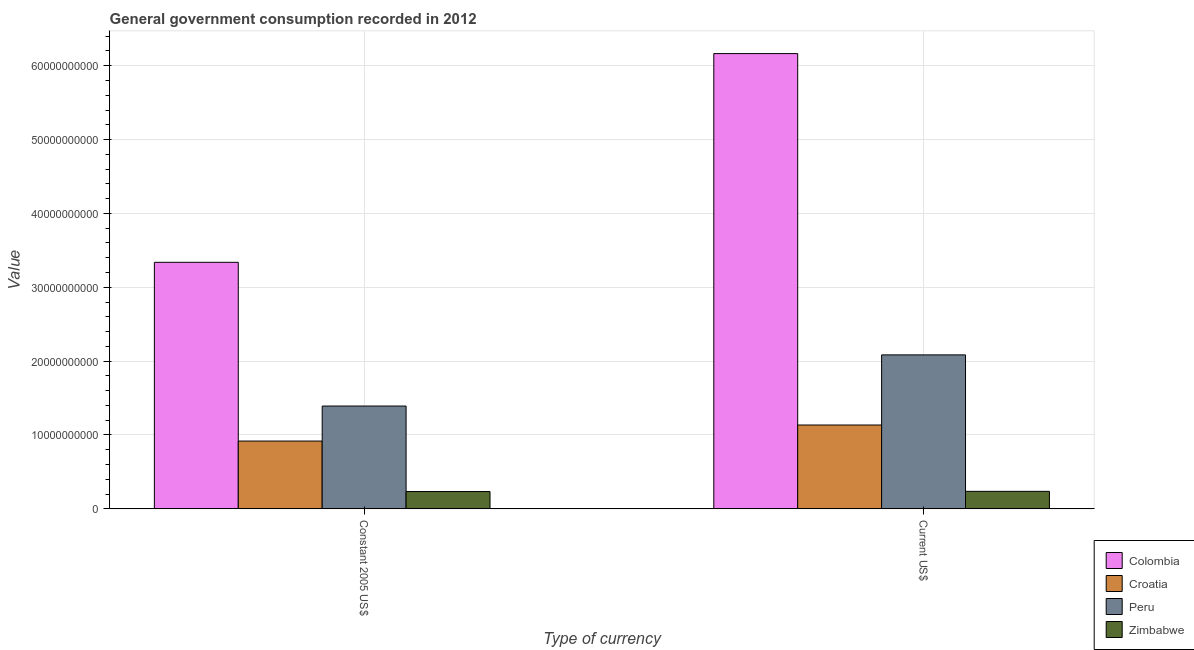Are the number of bars per tick equal to the number of legend labels?
Provide a succinct answer. Yes. How many bars are there on the 2nd tick from the left?
Keep it short and to the point. 4. How many bars are there on the 2nd tick from the right?
Keep it short and to the point. 4. What is the label of the 2nd group of bars from the left?
Provide a short and direct response. Current US$. What is the value consumed in constant 2005 us$ in Colombia?
Offer a very short reply. 3.34e+1. Across all countries, what is the maximum value consumed in current us$?
Ensure brevity in your answer.  6.16e+1. Across all countries, what is the minimum value consumed in current us$?
Your answer should be very brief. 2.37e+09. In which country was the value consumed in current us$ maximum?
Offer a very short reply. Colombia. In which country was the value consumed in constant 2005 us$ minimum?
Your response must be concise. Zimbabwe. What is the total value consumed in current us$ in the graph?
Make the answer very short. 9.62e+1. What is the difference between the value consumed in constant 2005 us$ in Peru and that in Croatia?
Your answer should be very brief. 4.74e+09. What is the difference between the value consumed in constant 2005 us$ in Croatia and the value consumed in current us$ in Peru?
Provide a succinct answer. -1.17e+1. What is the average value consumed in constant 2005 us$ per country?
Provide a succinct answer. 1.47e+1. What is the difference between the value consumed in current us$ and value consumed in constant 2005 us$ in Peru?
Your response must be concise. 6.93e+09. In how many countries, is the value consumed in current us$ greater than 48000000000 ?
Provide a succinct answer. 1. What is the ratio of the value consumed in constant 2005 us$ in Peru to that in Zimbabwe?
Your answer should be very brief. 5.94. Is the value consumed in current us$ in Croatia less than that in Colombia?
Provide a succinct answer. Yes. What does the 2nd bar from the left in Constant 2005 US$ represents?
Your answer should be very brief. Croatia. What does the 1st bar from the right in Constant 2005 US$ represents?
Your answer should be compact. Zimbabwe. How many bars are there?
Offer a very short reply. 8. What is the difference between two consecutive major ticks on the Y-axis?
Your response must be concise. 1.00e+1. Are the values on the major ticks of Y-axis written in scientific E-notation?
Provide a short and direct response. No. Does the graph contain any zero values?
Give a very brief answer. No. How are the legend labels stacked?
Provide a succinct answer. Vertical. What is the title of the graph?
Provide a succinct answer. General government consumption recorded in 2012. Does "South Sudan" appear as one of the legend labels in the graph?
Your answer should be very brief. No. What is the label or title of the X-axis?
Ensure brevity in your answer.  Type of currency. What is the label or title of the Y-axis?
Offer a very short reply. Value. What is the Value in Colombia in Constant 2005 US$?
Ensure brevity in your answer.  3.34e+1. What is the Value of Croatia in Constant 2005 US$?
Your answer should be very brief. 9.18e+09. What is the Value in Peru in Constant 2005 US$?
Your answer should be compact. 1.39e+1. What is the Value in Zimbabwe in Constant 2005 US$?
Provide a short and direct response. 2.34e+09. What is the Value in Colombia in Current US$?
Give a very brief answer. 6.16e+1. What is the Value in Croatia in Current US$?
Make the answer very short. 1.14e+1. What is the Value in Peru in Current US$?
Your response must be concise. 2.08e+1. What is the Value in Zimbabwe in Current US$?
Ensure brevity in your answer.  2.37e+09. Across all Type of currency, what is the maximum Value of Colombia?
Provide a short and direct response. 6.16e+1. Across all Type of currency, what is the maximum Value of Croatia?
Give a very brief answer. 1.14e+1. Across all Type of currency, what is the maximum Value in Peru?
Provide a short and direct response. 2.08e+1. Across all Type of currency, what is the maximum Value of Zimbabwe?
Your answer should be compact. 2.37e+09. Across all Type of currency, what is the minimum Value of Colombia?
Offer a very short reply. 3.34e+1. Across all Type of currency, what is the minimum Value in Croatia?
Your answer should be very brief. 9.18e+09. Across all Type of currency, what is the minimum Value of Peru?
Your answer should be very brief. 1.39e+1. Across all Type of currency, what is the minimum Value in Zimbabwe?
Your answer should be very brief. 2.34e+09. What is the total Value of Colombia in the graph?
Your answer should be compact. 9.50e+1. What is the total Value of Croatia in the graph?
Your response must be concise. 2.05e+1. What is the total Value of Peru in the graph?
Offer a terse response. 3.48e+1. What is the total Value of Zimbabwe in the graph?
Give a very brief answer. 4.71e+09. What is the difference between the Value of Colombia in Constant 2005 US$ and that in Current US$?
Offer a very short reply. -2.83e+1. What is the difference between the Value of Croatia in Constant 2005 US$ and that in Current US$?
Your answer should be compact. -2.17e+09. What is the difference between the Value in Peru in Constant 2005 US$ and that in Current US$?
Your answer should be very brief. -6.93e+09. What is the difference between the Value of Zimbabwe in Constant 2005 US$ and that in Current US$?
Your response must be concise. -2.88e+07. What is the difference between the Value of Colombia in Constant 2005 US$ and the Value of Croatia in Current US$?
Your response must be concise. 2.20e+1. What is the difference between the Value of Colombia in Constant 2005 US$ and the Value of Peru in Current US$?
Provide a short and direct response. 1.25e+1. What is the difference between the Value of Colombia in Constant 2005 US$ and the Value of Zimbabwe in Current US$?
Your response must be concise. 3.10e+1. What is the difference between the Value of Croatia in Constant 2005 US$ and the Value of Peru in Current US$?
Offer a very short reply. -1.17e+1. What is the difference between the Value of Croatia in Constant 2005 US$ and the Value of Zimbabwe in Current US$?
Give a very brief answer. 6.81e+09. What is the difference between the Value of Peru in Constant 2005 US$ and the Value of Zimbabwe in Current US$?
Your answer should be compact. 1.16e+1. What is the average Value of Colombia per Type of currency?
Give a very brief answer. 4.75e+1. What is the average Value in Croatia per Type of currency?
Your answer should be compact. 1.03e+1. What is the average Value of Peru per Type of currency?
Provide a short and direct response. 1.74e+1. What is the average Value of Zimbabwe per Type of currency?
Offer a very short reply. 2.36e+09. What is the difference between the Value in Colombia and Value in Croatia in Constant 2005 US$?
Give a very brief answer. 2.42e+1. What is the difference between the Value in Colombia and Value in Peru in Constant 2005 US$?
Offer a terse response. 1.95e+1. What is the difference between the Value in Colombia and Value in Zimbabwe in Constant 2005 US$?
Your response must be concise. 3.10e+1. What is the difference between the Value of Croatia and Value of Peru in Constant 2005 US$?
Offer a terse response. -4.74e+09. What is the difference between the Value in Croatia and Value in Zimbabwe in Constant 2005 US$?
Your response must be concise. 6.84e+09. What is the difference between the Value in Peru and Value in Zimbabwe in Constant 2005 US$?
Give a very brief answer. 1.16e+1. What is the difference between the Value of Colombia and Value of Croatia in Current US$?
Give a very brief answer. 5.03e+1. What is the difference between the Value of Colombia and Value of Peru in Current US$?
Make the answer very short. 4.08e+1. What is the difference between the Value of Colombia and Value of Zimbabwe in Current US$?
Give a very brief answer. 5.93e+1. What is the difference between the Value in Croatia and Value in Peru in Current US$?
Offer a terse response. -9.50e+09. What is the difference between the Value of Croatia and Value of Zimbabwe in Current US$?
Your answer should be very brief. 8.98e+09. What is the difference between the Value of Peru and Value of Zimbabwe in Current US$?
Your response must be concise. 1.85e+1. What is the ratio of the Value in Colombia in Constant 2005 US$ to that in Current US$?
Your answer should be compact. 0.54. What is the ratio of the Value of Croatia in Constant 2005 US$ to that in Current US$?
Your answer should be compact. 0.81. What is the ratio of the Value in Peru in Constant 2005 US$ to that in Current US$?
Your answer should be very brief. 0.67. What is the ratio of the Value in Zimbabwe in Constant 2005 US$ to that in Current US$?
Give a very brief answer. 0.99. What is the difference between the highest and the second highest Value in Colombia?
Ensure brevity in your answer.  2.83e+1. What is the difference between the highest and the second highest Value in Croatia?
Provide a succinct answer. 2.17e+09. What is the difference between the highest and the second highest Value of Peru?
Provide a succinct answer. 6.93e+09. What is the difference between the highest and the second highest Value of Zimbabwe?
Provide a succinct answer. 2.88e+07. What is the difference between the highest and the lowest Value in Colombia?
Ensure brevity in your answer.  2.83e+1. What is the difference between the highest and the lowest Value in Croatia?
Provide a succinct answer. 2.17e+09. What is the difference between the highest and the lowest Value in Peru?
Ensure brevity in your answer.  6.93e+09. What is the difference between the highest and the lowest Value in Zimbabwe?
Offer a terse response. 2.88e+07. 